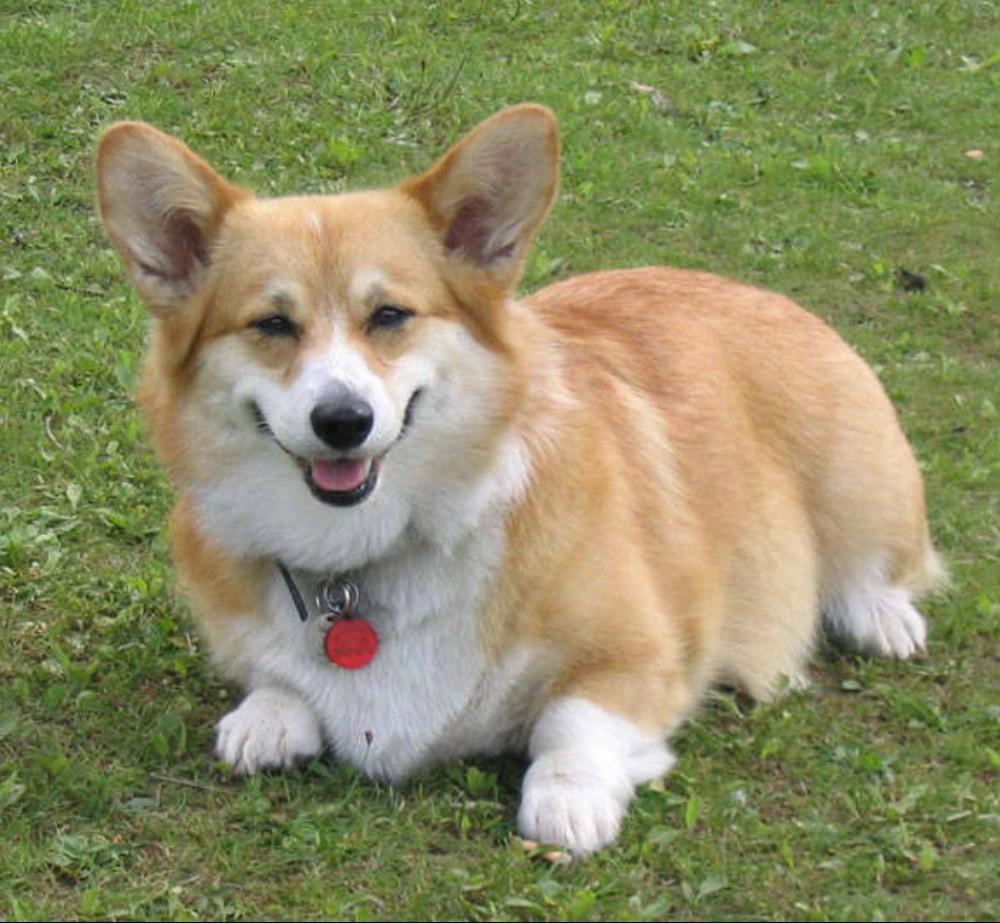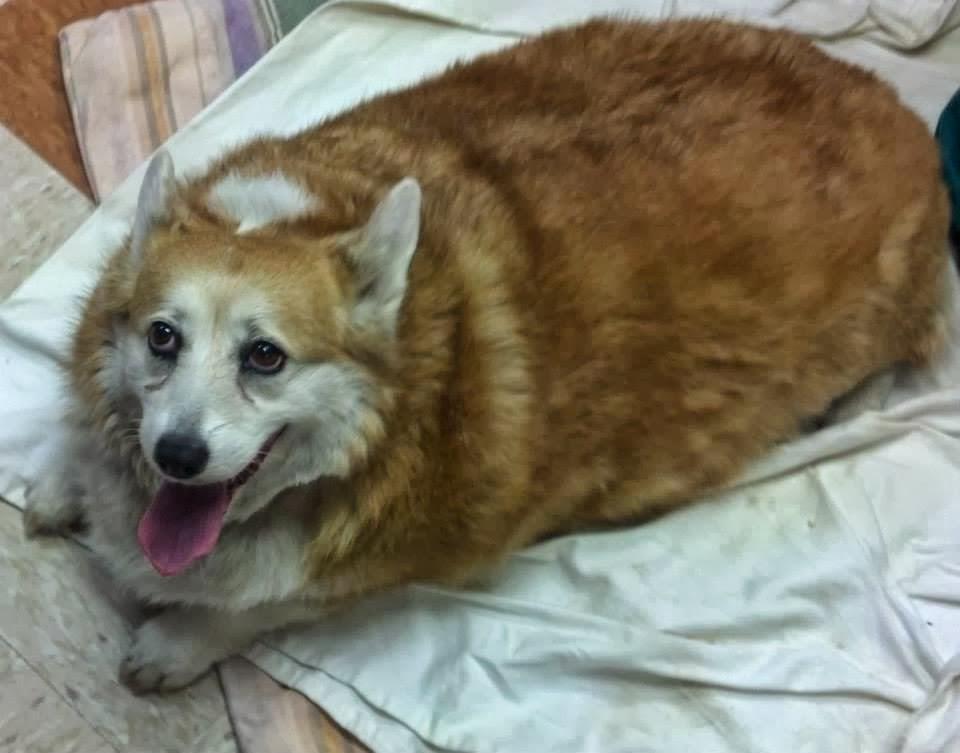The first image is the image on the left, the second image is the image on the right. Considering the images on both sides, is "There are at least three dogs." valid? Answer yes or no. No. The first image is the image on the left, the second image is the image on the right. For the images shown, is this caption "One image contains at least twice as many corgi dogs as the other image." true? Answer yes or no. No. 